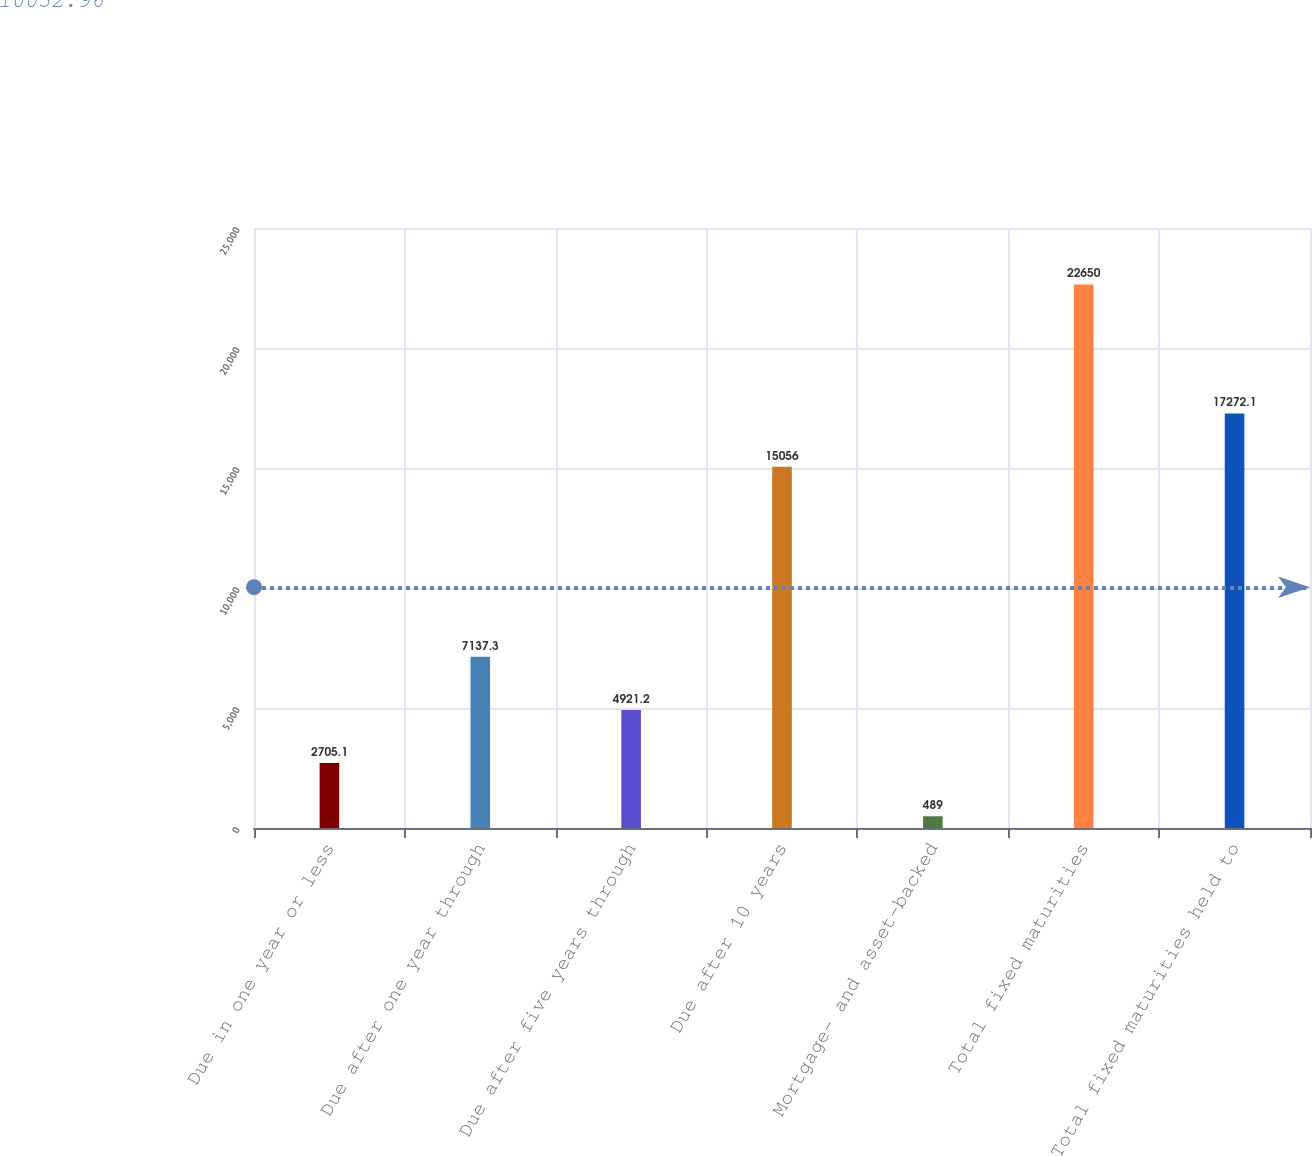Convert chart. <chart><loc_0><loc_0><loc_500><loc_500><bar_chart><fcel>Due in one year or less<fcel>Due after one year through<fcel>Due after five years through<fcel>Due after 10 years<fcel>Mortgage- and asset-backed<fcel>Total fixed maturities<fcel>Total fixed maturities held to<nl><fcel>2705.1<fcel>7137.3<fcel>4921.2<fcel>15056<fcel>489<fcel>22650<fcel>17272.1<nl></chart> 